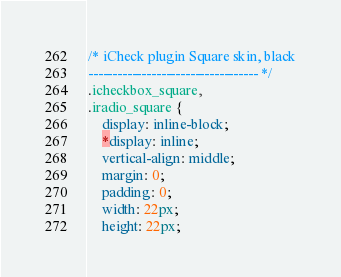Convert code to text. <code><loc_0><loc_0><loc_500><loc_500><_CSS_>/* iCheck plugin Square skin, black
----------------------------------- */
.icheckbox_square,
.iradio_square {
    display: inline-block;
    *display: inline;
    vertical-align: middle;
    margin: 0;
    padding: 0;
    width: 22px;
    height: 22px;</code> 